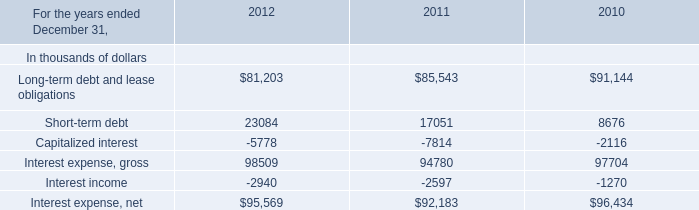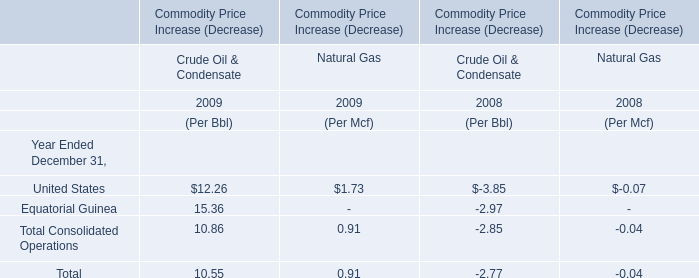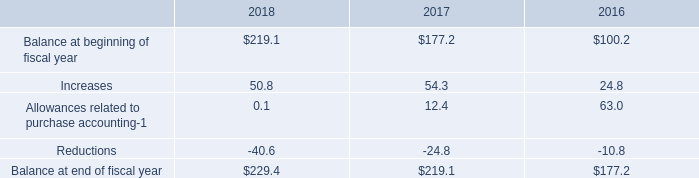What was the total amount of Crude Oil & Condensate greater than 12 in 2009? 
Computations: (12.26 + 15.36)
Answer: 27.62. how much has the balance increased in a percentage from 2016 to 2018? 
Computations: ((229.4 - 177.2) / 177.2)
Answer: 0.29458. 